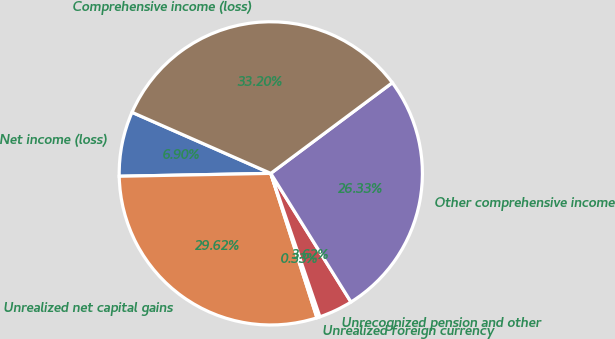<chart> <loc_0><loc_0><loc_500><loc_500><pie_chart><fcel>Net income (loss)<fcel>Unrealized net capital gains<fcel>Unrealized foreign currency<fcel>Unrecognized pension and other<fcel>Other comprehensive income<fcel>Comprehensive income (loss)<nl><fcel>6.9%<fcel>29.62%<fcel>0.33%<fcel>3.62%<fcel>26.33%<fcel>33.2%<nl></chart> 